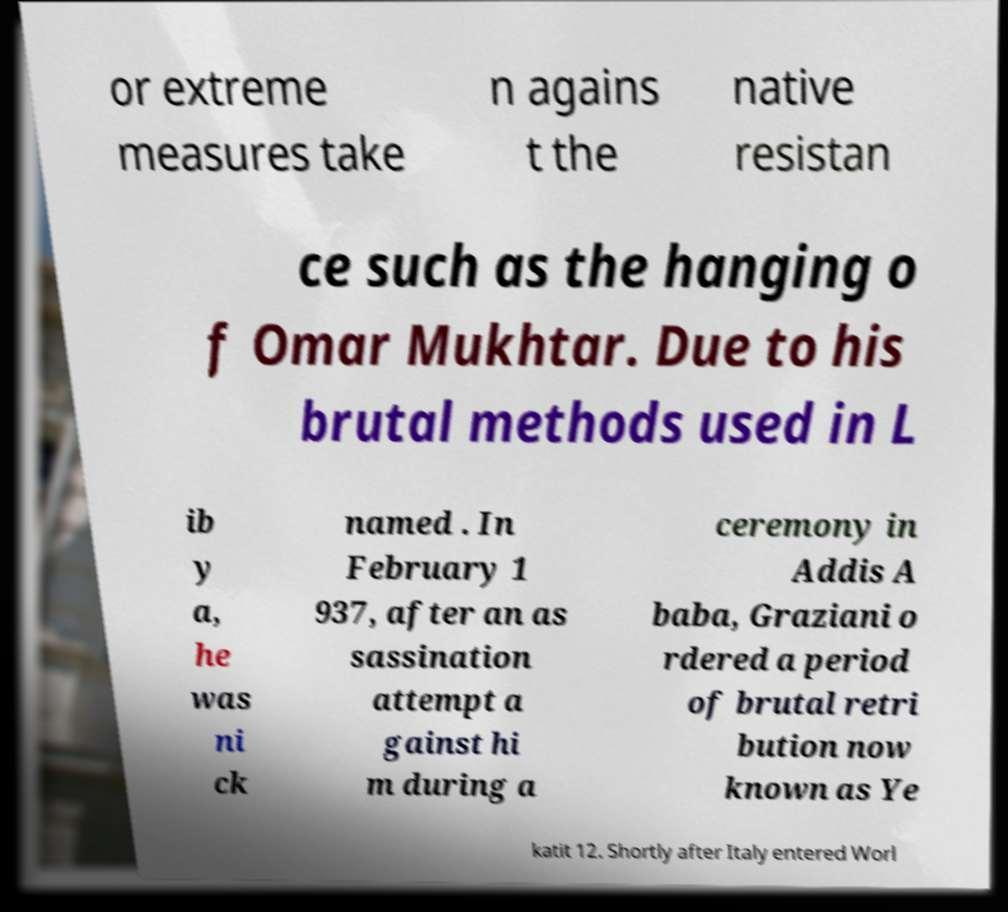Could you extract and type out the text from this image? or extreme measures take n agains t the native resistan ce such as the hanging o f Omar Mukhtar. Due to his brutal methods used in L ib y a, he was ni ck named . In February 1 937, after an as sassination attempt a gainst hi m during a ceremony in Addis A baba, Graziani o rdered a period of brutal retri bution now known as Ye katit 12. Shortly after Italy entered Worl 